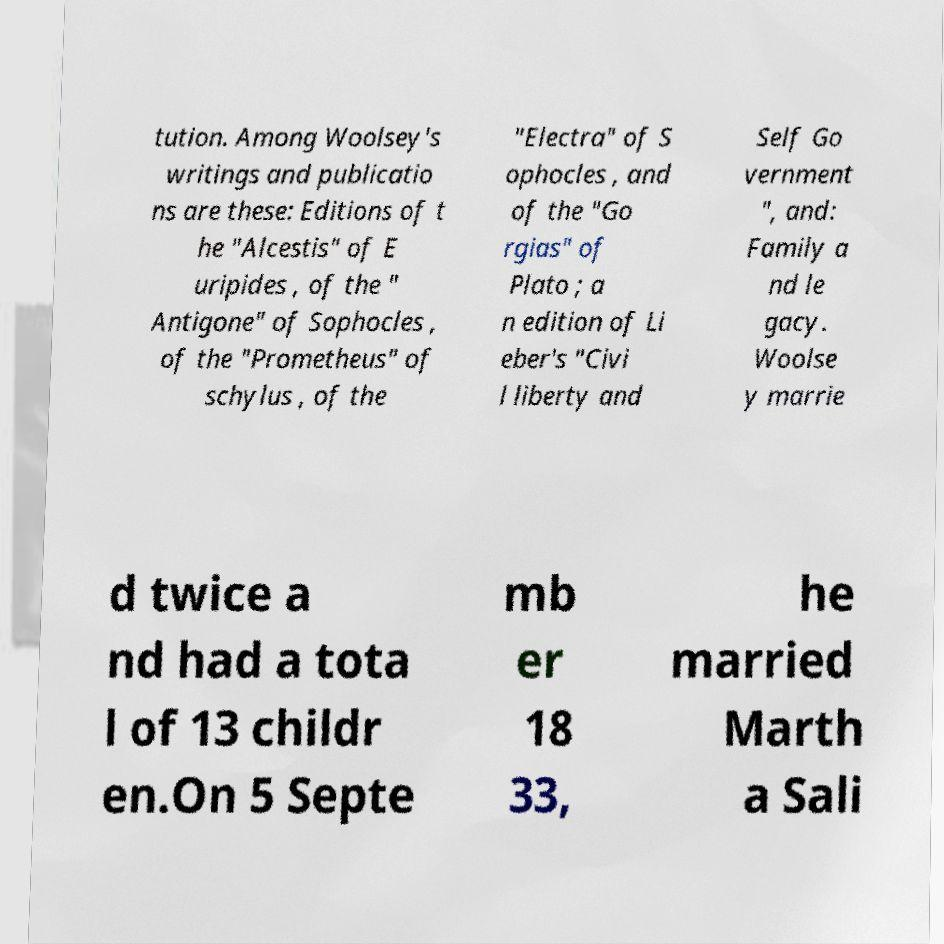There's text embedded in this image that I need extracted. Can you transcribe it verbatim? tution. Among Woolsey's writings and publicatio ns are these: Editions of t he "Alcestis" of E uripides , of the " Antigone" of Sophocles , of the "Prometheus" of schylus , of the "Electra" of S ophocles , and of the "Go rgias" of Plato ; a n edition of Li eber's "Civi l liberty and Self Go vernment ", and: Family a nd le gacy. Woolse y marrie d twice a nd had a tota l of 13 childr en.On 5 Septe mb er 18 33, he married Marth a Sali 